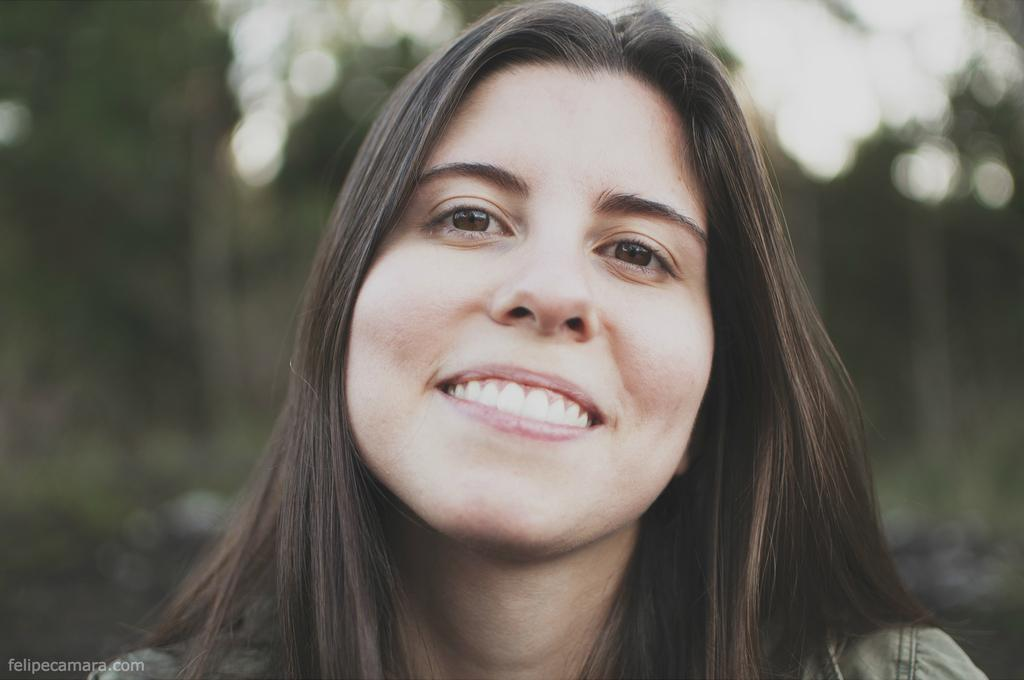Who is present in the image? There is a woman in the image. What is the woman's expression? The woman is smiling. Can you describe any additional features of the image? There is a watermark in the image, and the background is blurred. What type of quill is the woman holding in the image? There is no quill present in the image. Can you tell me how many horses are visible in the image? There are no horses visible in the image. 